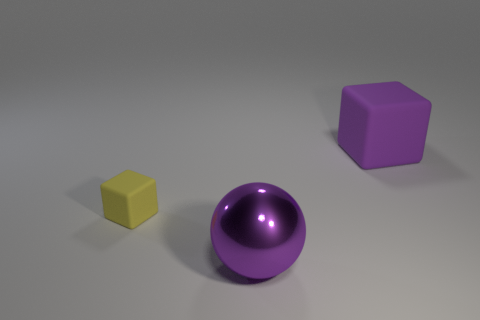There is a thing that is the same color as the large cube; what shape is it?
Offer a terse response. Sphere. How many matte things are the same color as the metallic object?
Your answer should be compact. 1. There is a large thing that is the same color as the large rubber cube; what material is it?
Keep it short and to the point. Metal. Is there any other thing that has the same material as the purple sphere?
Give a very brief answer. No. What is the material of the purple block that is the same size as the purple shiny thing?
Your answer should be compact. Rubber. There is a object that is behind the purple sphere and on the left side of the purple rubber object; what is its material?
Your response must be concise. Rubber. What number of objects have the same size as the metal ball?
Your answer should be compact. 1. There is a tiny yellow thing that is the same shape as the big rubber thing; what is it made of?
Keep it short and to the point. Rubber. How many things are either things in front of the small yellow cube or small matte blocks that are behind the shiny ball?
Your answer should be very brief. 2. Do the large purple shiny thing and the rubber object in front of the large rubber object have the same shape?
Your answer should be very brief. No. 